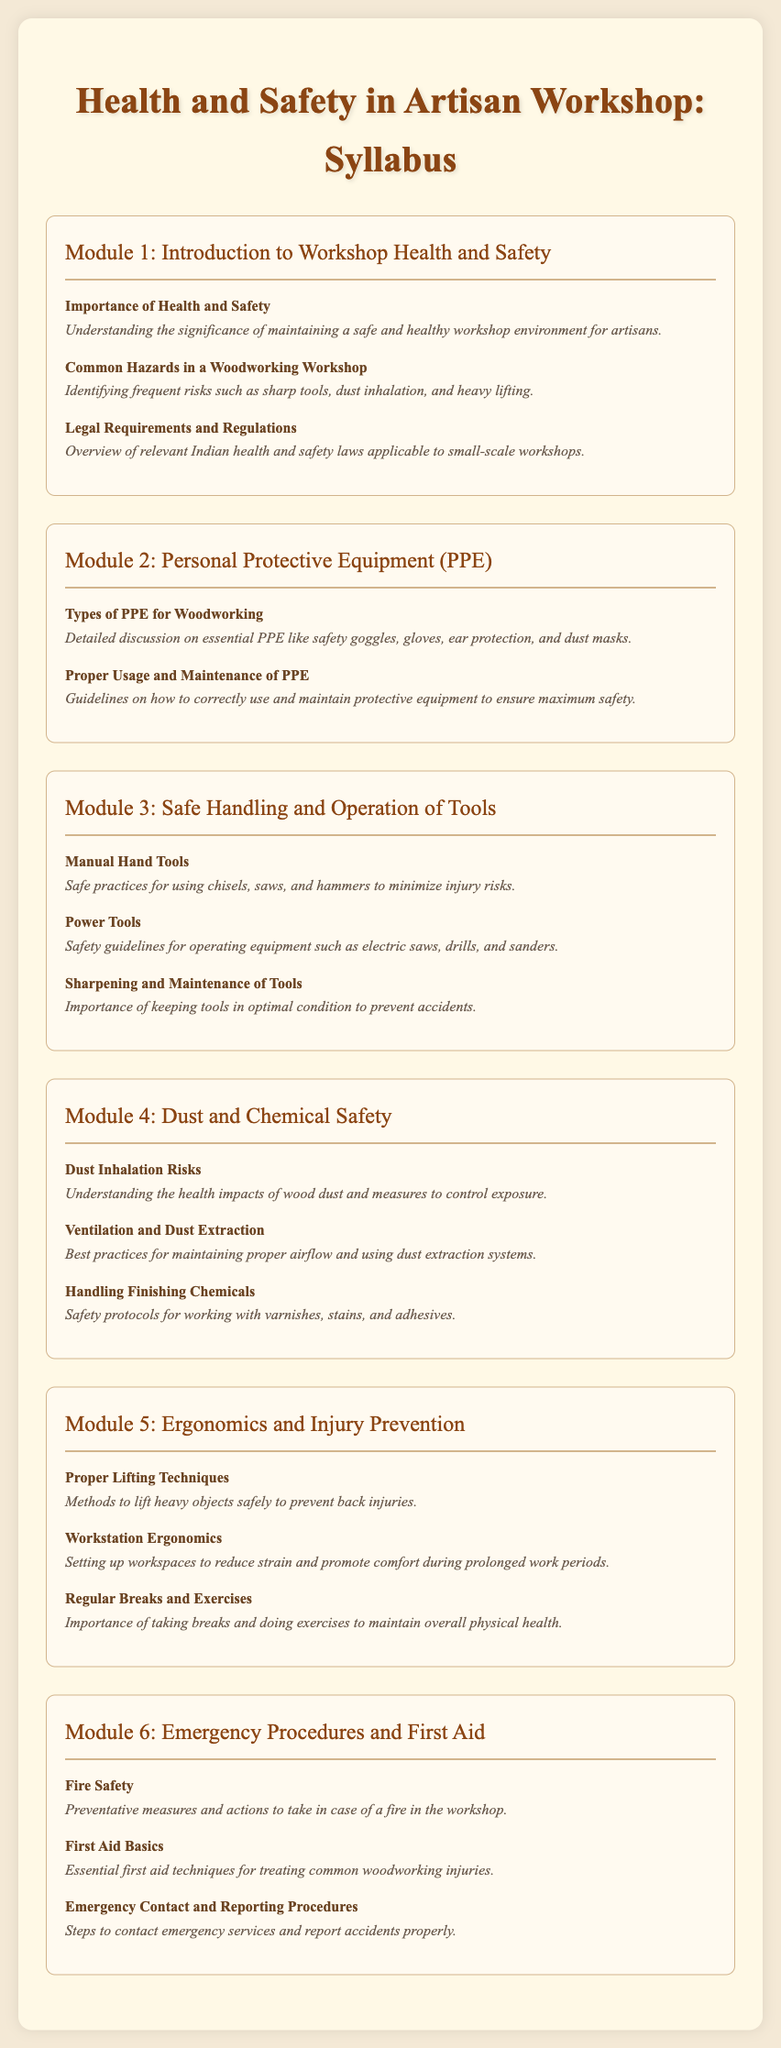What is the title of the syllabus? The title is prominently displayed at the top of the document, describing the subject matter focused on artisan workshops.
Answer: Health and Safety in Artisan Workshop: Syllabus How many modules are included in the syllabus? The document lists separate sections for organized learning, each marked as a module.
Answer: Six What is the first topic in Module 1? The first topic under the introductory module addresses a critical aspect of workshop safety.
Answer: Importance of Health and Safety Which type of PPE is mentioned for woodworking? The syllabus outlines essential protective gear necessary for artisans working in the workshop.
Answer: Safety goggles What is one key method for preventing back injuries? The syllabus emphasizes a critical technique for lifting safely throughout the injury prevention module.
Answer: Proper Lifting Techniques What does Module 6 focus on? This module is dedicated to preparing artisans for emergency situations that may arise in the workshop environment.
Answer: Emergency Procedures and First Aid What is emphasized in the topic "Ventilation and Dust Extraction"? There are best practices related to maintaining air quality while working with wood and avoiding health risks in this topic.
Answer: Proper airflow and using dust extraction systems Which module discusses the handling of finishing chemicals? This topic falls under specific safety considerations regarding materials that may pose health risks.
Answer: Module 4: Dust and Chemical Safety 